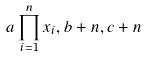<formula> <loc_0><loc_0><loc_500><loc_500>a \prod _ { i = 1 } ^ { n } x _ { i } , b + n , c + n</formula> 